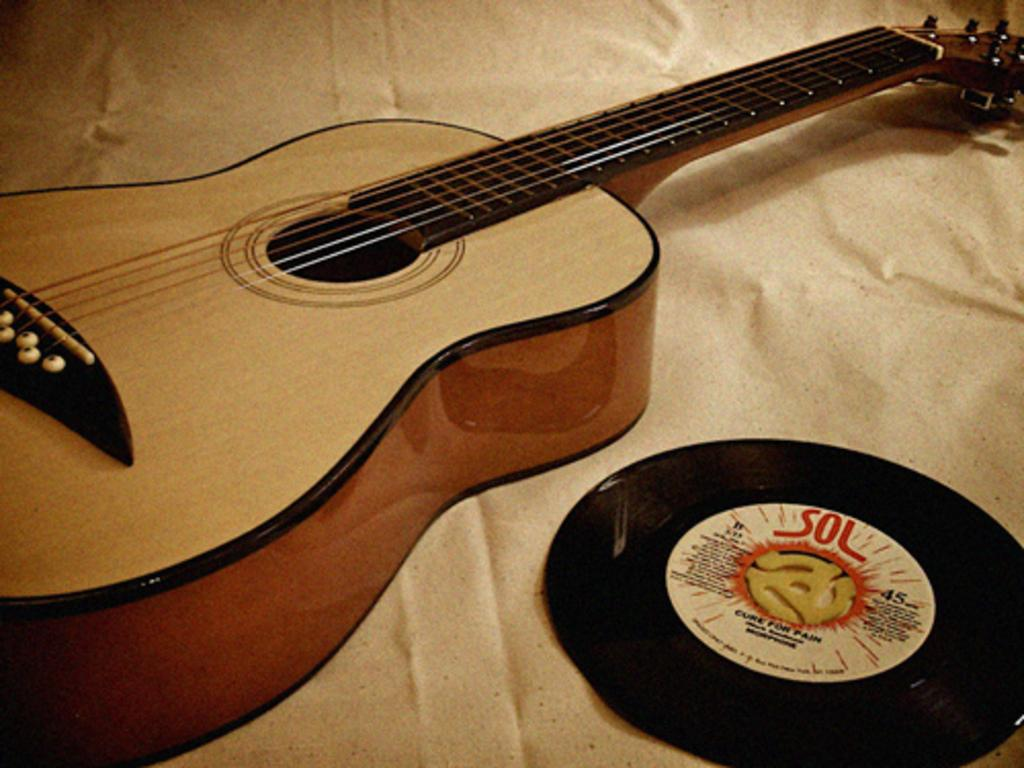What type of musical instrument is in the image? There is a brown and cream color guitar in the image. Where is the guitar located in the image? The guitar is placed on the bed. What other object is on the bed in the image? There is a disc-shaped object on the bed. What is the weather like in the image? The provided facts do not mention any information about the weather, so it cannot be determined from the image. 